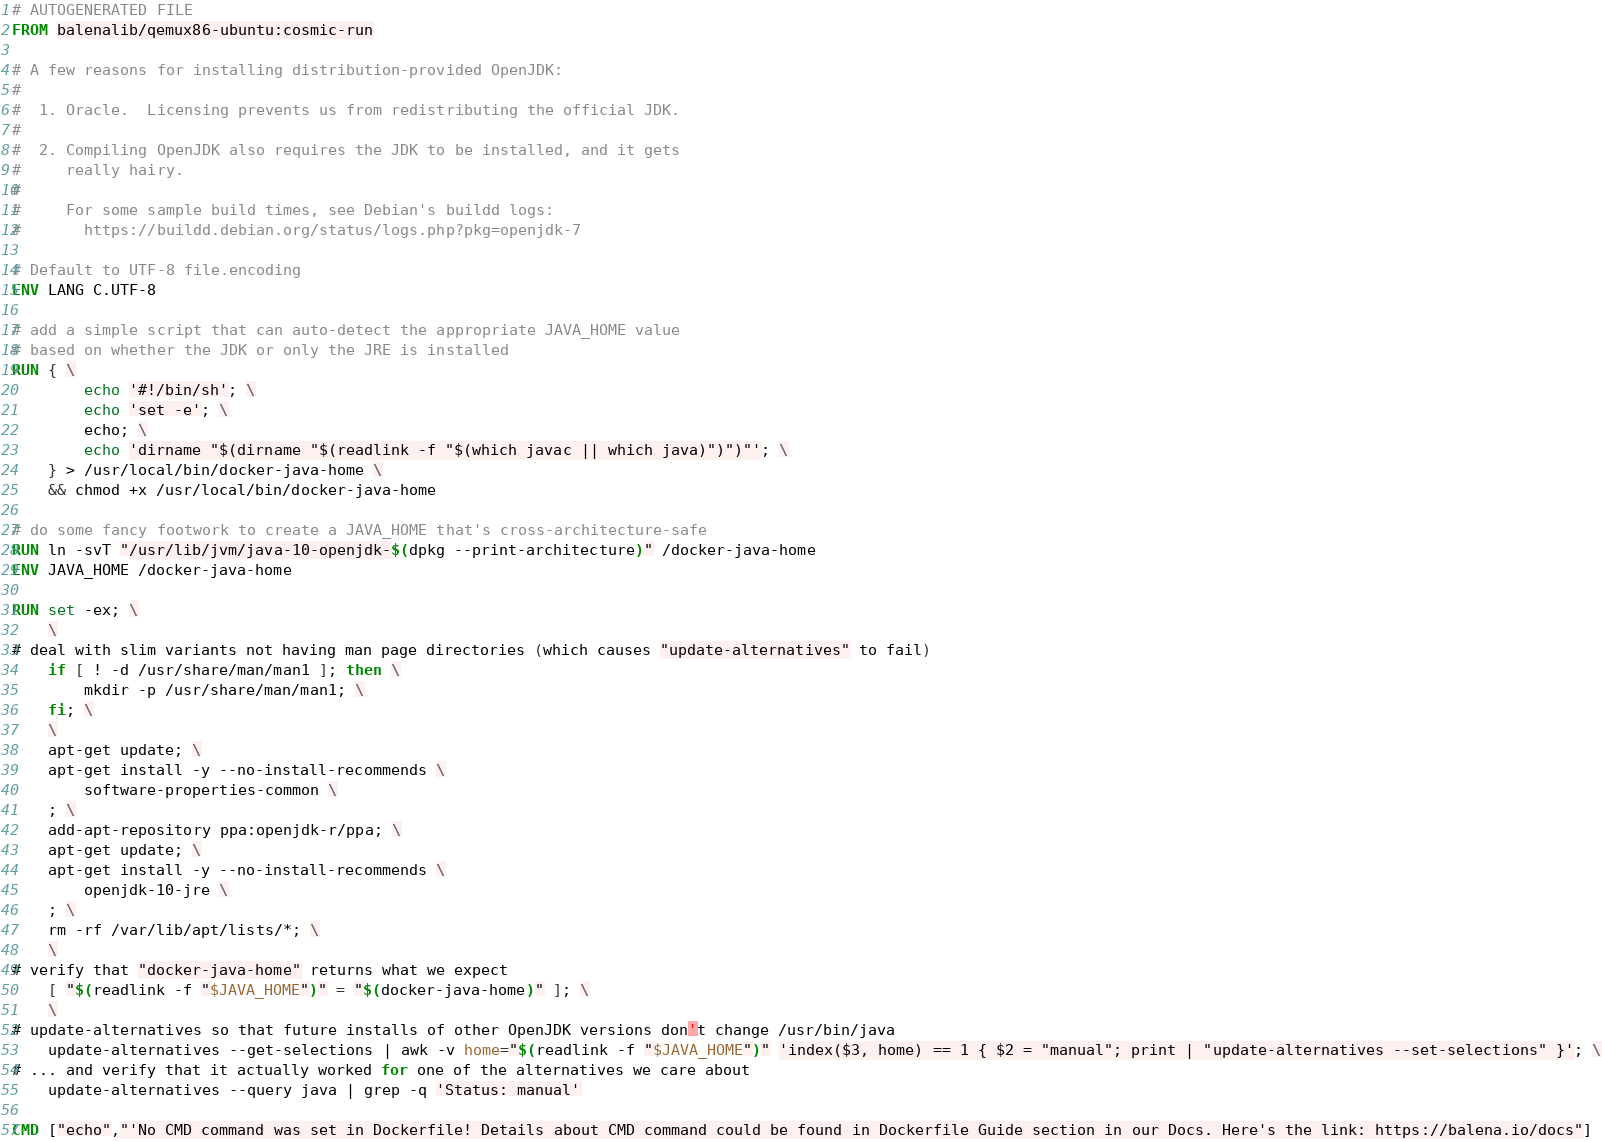Convert code to text. <code><loc_0><loc_0><loc_500><loc_500><_Dockerfile_># AUTOGENERATED FILE
FROM balenalib/qemux86-ubuntu:cosmic-run

# A few reasons for installing distribution-provided OpenJDK:
#
#  1. Oracle.  Licensing prevents us from redistributing the official JDK.
#
#  2. Compiling OpenJDK also requires the JDK to be installed, and it gets
#     really hairy.
#
#     For some sample build times, see Debian's buildd logs:
#       https://buildd.debian.org/status/logs.php?pkg=openjdk-7

# Default to UTF-8 file.encoding
ENV LANG C.UTF-8

# add a simple script that can auto-detect the appropriate JAVA_HOME value
# based on whether the JDK or only the JRE is installed
RUN { \
		echo '#!/bin/sh'; \
		echo 'set -e'; \
		echo; \
		echo 'dirname "$(dirname "$(readlink -f "$(which javac || which java)")")"'; \
	} > /usr/local/bin/docker-java-home \
	&& chmod +x /usr/local/bin/docker-java-home

# do some fancy footwork to create a JAVA_HOME that's cross-architecture-safe
RUN ln -svT "/usr/lib/jvm/java-10-openjdk-$(dpkg --print-architecture)" /docker-java-home
ENV JAVA_HOME /docker-java-home

RUN set -ex; \
	\
# deal with slim variants not having man page directories (which causes "update-alternatives" to fail)
	if [ ! -d /usr/share/man/man1 ]; then \
		mkdir -p /usr/share/man/man1; \
	fi; \
	\
	apt-get update; \
	apt-get install -y --no-install-recommends \
		software-properties-common \
	; \
	add-apt-repository ppa:openjdk-r/ppa; \
	apt-get update; \
	apt-get install -y --no-install-recommends \
		openjdk-10-jre \
	; \
	rm -rf /var/lib/apt/lists/*; \
	\
# verify that "docker-java-home" returns what we expect
	[ "$(readlink -f "$JAVA_HOME")" = "$(docker-java-home)" ]; \
	\
# update-alternatives so that future installs of other OpenJDK versions don't change /usr/bin/java
	update-alternatives --get-selections | awk -v home="$(readlink -f "$JAVA_HOME")" 'index($3, home) == 1 { $2 = "manual"; print | "update-alternatives --set-selections" }'; \
# ... and verify that it actually worked for one of the alternatives we care about
	update-alternatives --query java | grep -q 'Status: manual'

CMD ["echo","'No CMD command was set in Dockerfile! Details about CMD command could be found in Dockerfile Guide section in our Docs. Here's the link: https://balena.io/docs"]</code> 